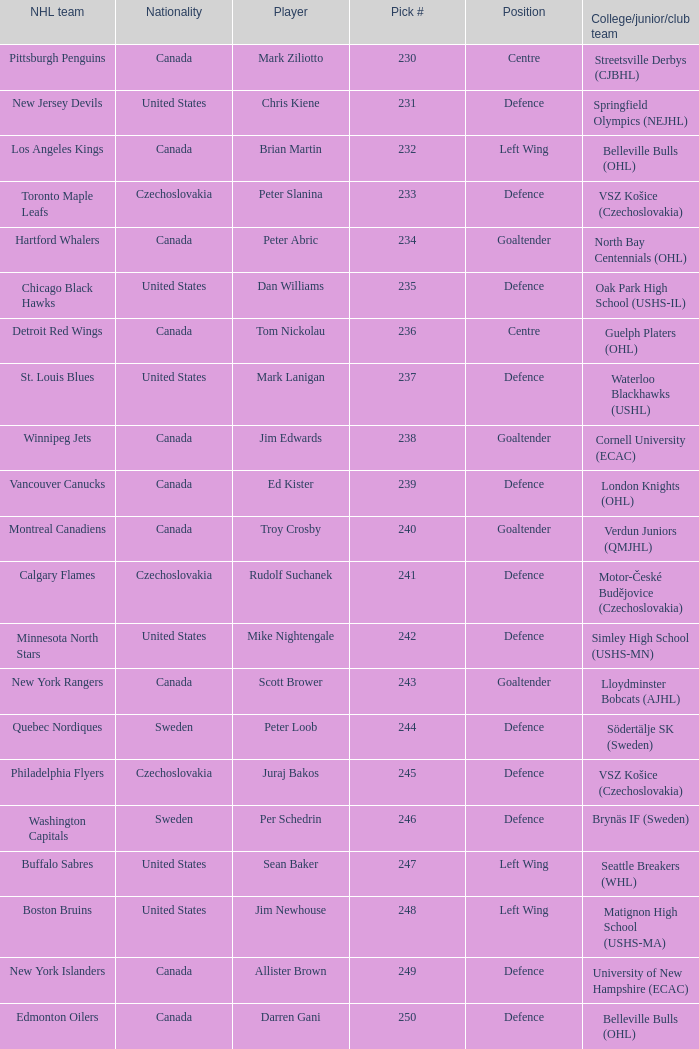To which organziation does the  winnipeg jets belong to? Cornell University (ECAC). 